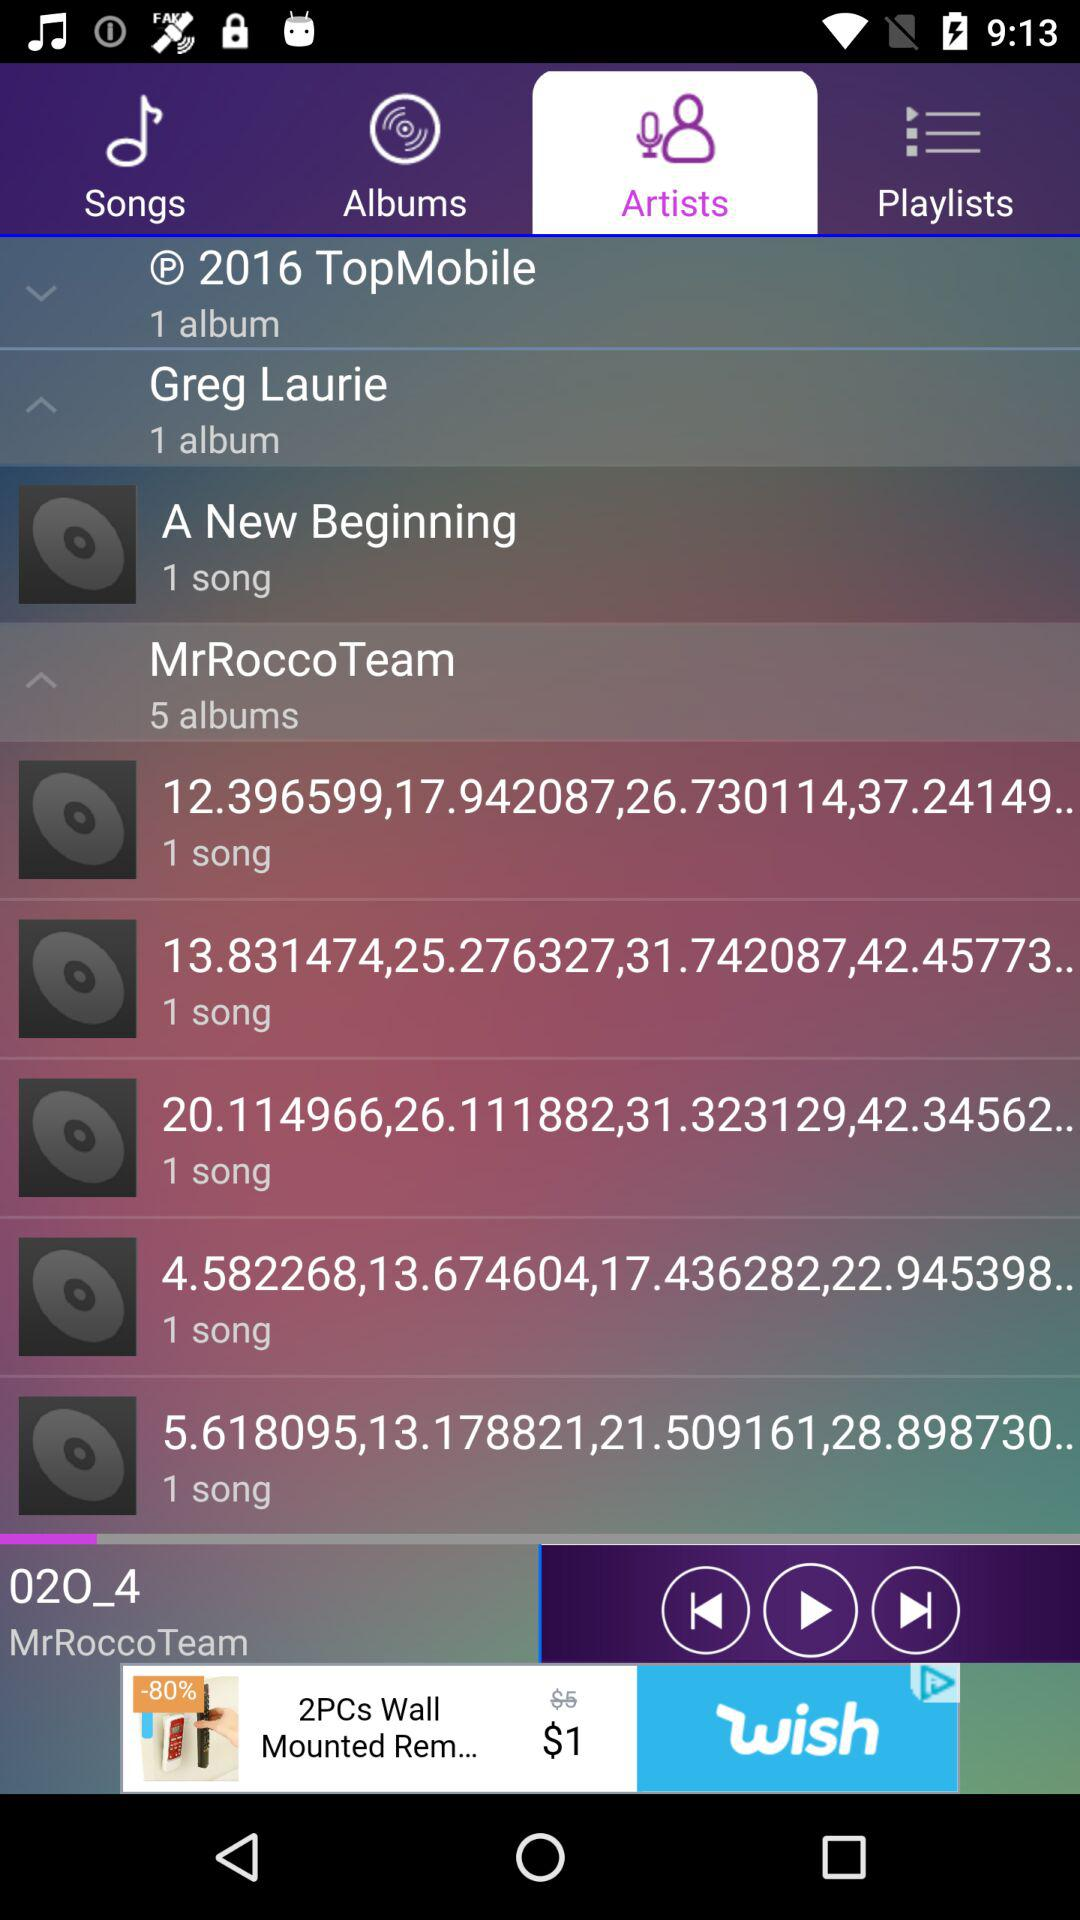Which song was last played? The last played song was "02O_4". 